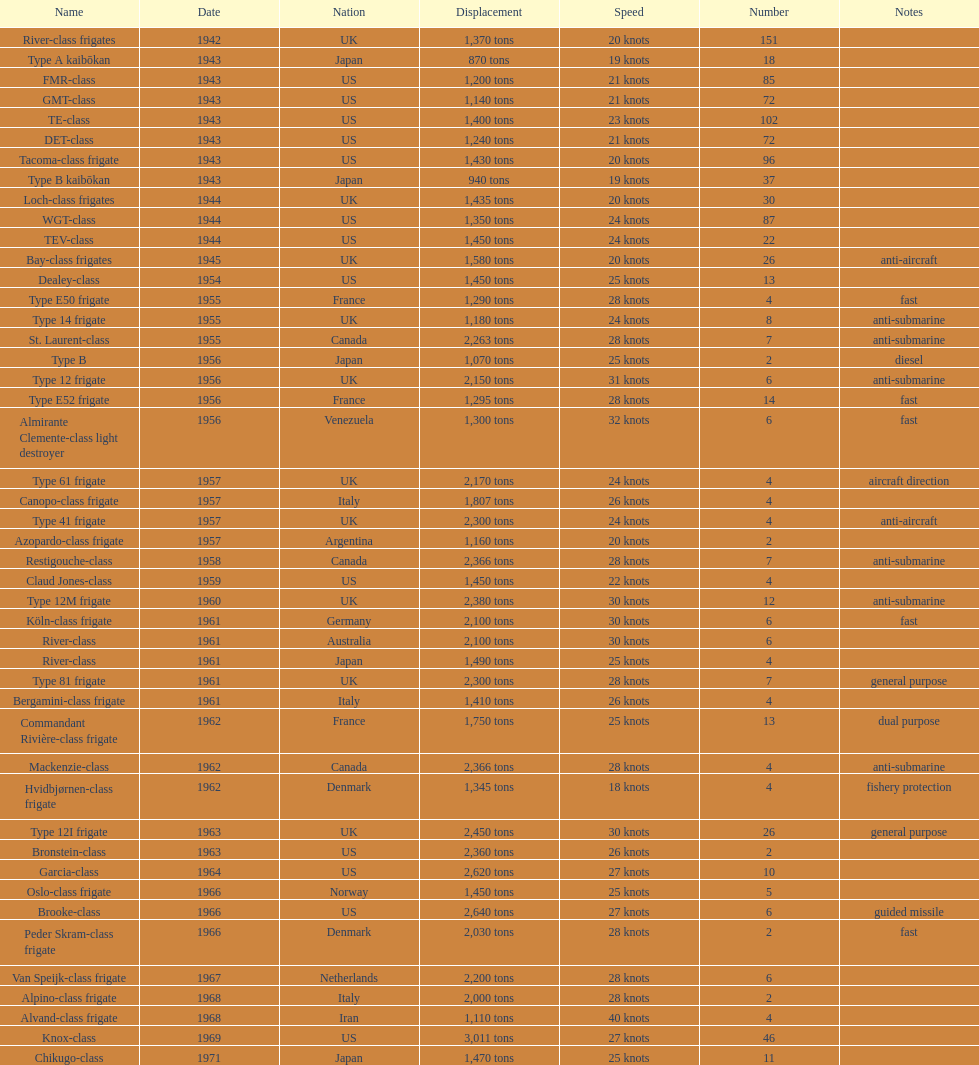How many tons of displacement does type b have? 940 tons. 